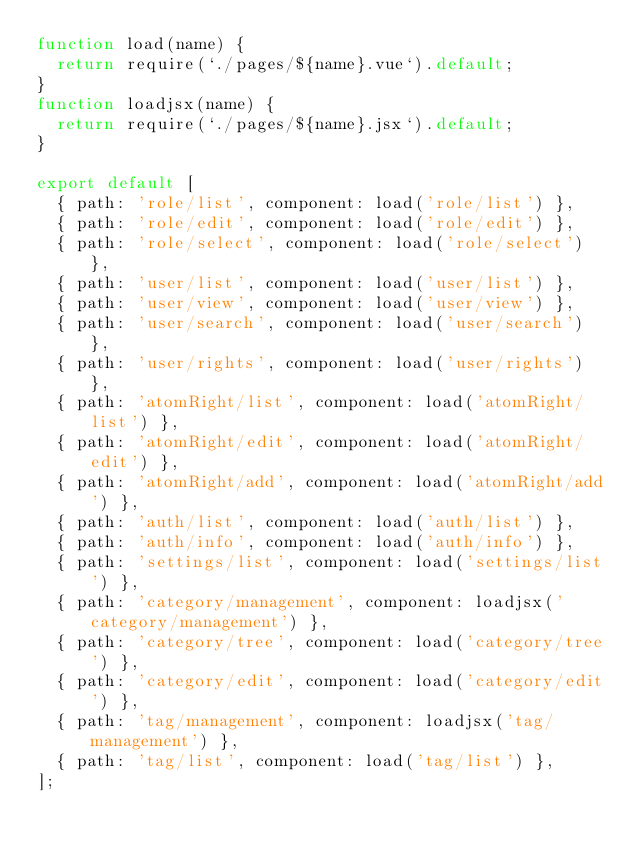Convert code to text. <code><loc_0><loc_0><loc_500><loc_500><_JavaScript_>function load(name) {
  return require(`./pages/${name}.vue`).default;
}
function loadjsx(name) {
  return require(`./pages/${name}.jsx`).default;
}

export default [
  { path: 'role/list', component: load('role/list') },
  { path: 'role/edit', component: load('role/edit') },
  { path: 'role/select', component: load('role/select') },
  { path: 'user/list', component: load('user/list') },
  { path: 'user/view', component: load('user/view') },
  { path: 'user/search', component: load('user/search') },
  { path: 'user/rights', component: load('user/rights') },
  { path: 'atomRight/list', component: load('atomRight/list') },
  { path: 'atomRight/edit', component: load('atomRight/edit') },
  { path: 'atomRight/add', component: load('atomRight/add') },
  { path: 'auth/list', component: load('auth/list') },
  { path: 'auth/info', component: load('auth/info') },
  { path: 'settings/list', component: load('settings/list') },
  { path: 'category/management', component: loadjsx('category/management') },
  { path: 'category/tree', component: load('category/tree') },
  { path: 'category/edit', component: load('category/edit') },
  { path: 'tag/management', component: loadjsx('tag/management') },
  { path: 'tag/list', component: load('tag/list') },
];
</code> 